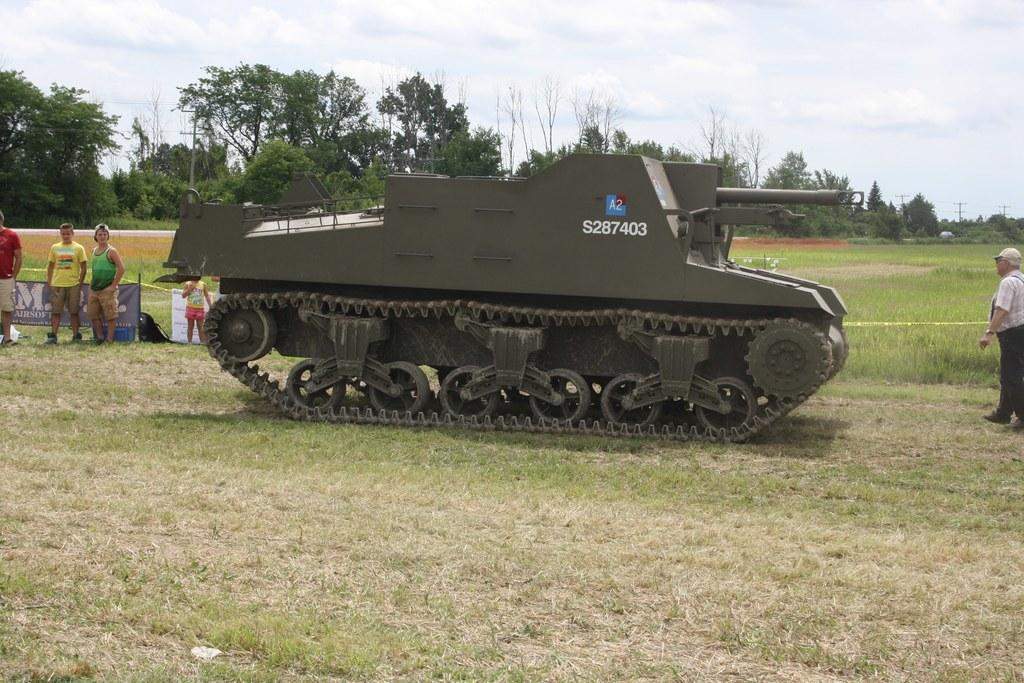What is the main object on the ground in the image? There is a tank on the ground in the image. What else can be seen in the image besides the tank? There are people standing in the image. What type of vegetation is visible in the background of the image? There are trees in the background of the image. What is visible in the sky in the image? The sky is visible in the background of the image. What type of ground surface is present in the image? There is grass in the image. How many houses can be seen in the image? There are no houses present in the image. What type of authority figure is standing near the tank in the image? There is no authority figure mentioned or visible in the image. 